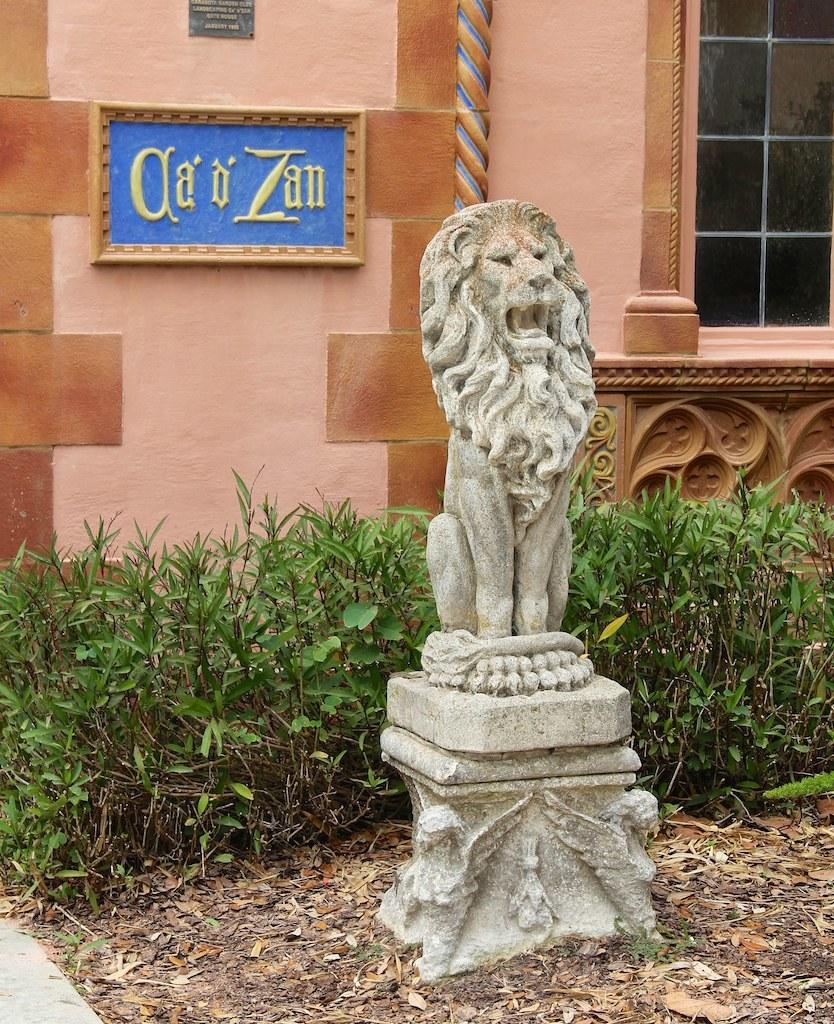What is the main subject of the image? There is a sculpture in the image. What other elements can be seen in the image? There are plants, a building in the background, and a board with text. How many cattle are present in the image? There are no cattle present in the image. What type of cars can be seen driving by in the image? There are no cars present in the image. 